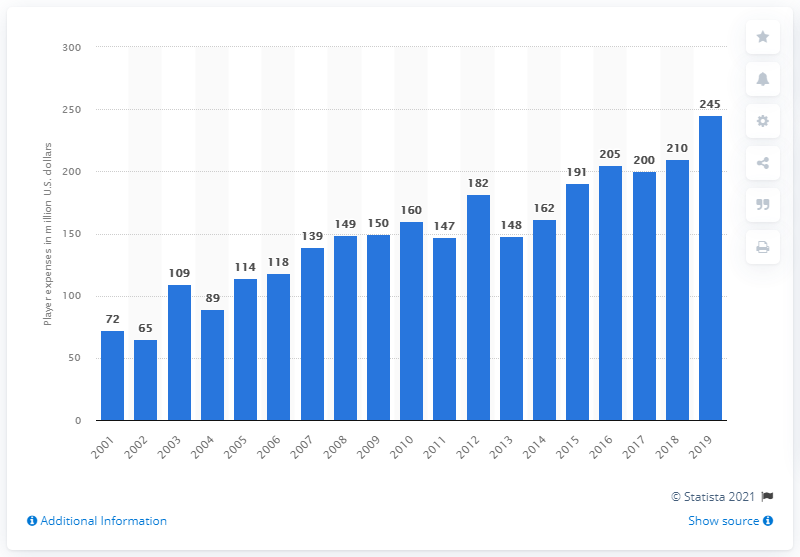Highlight a few significant elements in this photo. The New Orleans Saints' player expenses in the 2019 season were 245. 